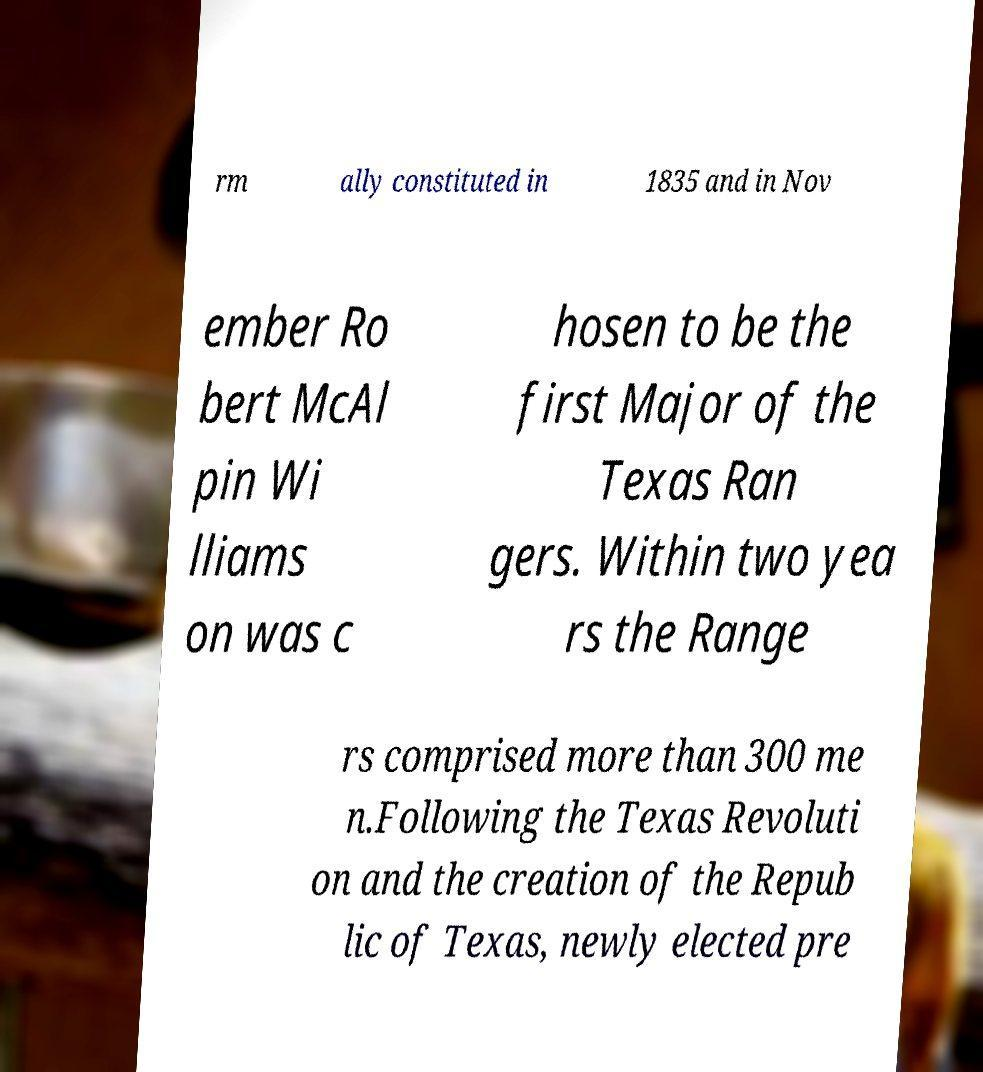There's text embedded in this image that I need extracted. Can you transcribe it verbatim? rm ally constituted in 1835 and in Nov ember Ro bert McAl pin Wi lliams on was c hosen to be the first Major of the Texas Ran gers. Within two yea rs the Range rs comprised more than 300 me n.Following the Texas Revoluti on and the creation of the Repub lic of Texas, newly elected pre 